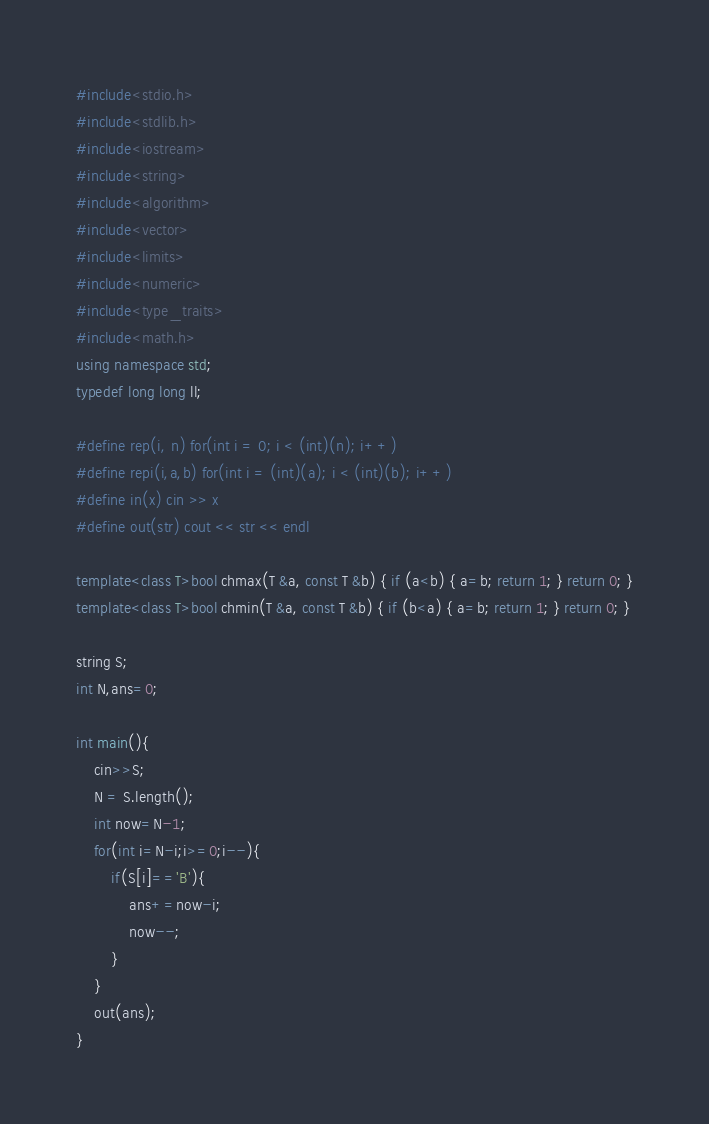Convert code to text. <code><loc_0><loc_0><loc_500><loc_500><_C++_>#include<stdio.h>
#include<stdlib.h>
#include<iostream>
#include<string>
#include<algorithm>
#include<vector> 
#include<limits>
#include<numeric>
#include<type_traits>
#include<math.h>
using namespace std;
typedef long long ll;

#define rep(i, n) for(int i = 0; i < (int)(n); i++)
#define repi(i,a,b) for(int i = (int)(a); i < (int)(b); i++)
#define in(x) cin >> x
#define out(str) cout << str << endl

template<class T>bool chmax(T &a, const T &b) { if (a<b) { a=b; return 1; } return 0; }
template<class T>bool chmin(T &a, const T &b) { if (b<a) { a=b; return 1; } return 0; }

string S;
int N,ans=0;

int main(){
    cin>>S;
    N = S.length();
    int now=N-1;
    for(int i=N-i;i>=0;i--){
        if(S[i]=='B'){
            ans+=now-i;
            now--;
        }
    }
    out(ans);
}
</code> 